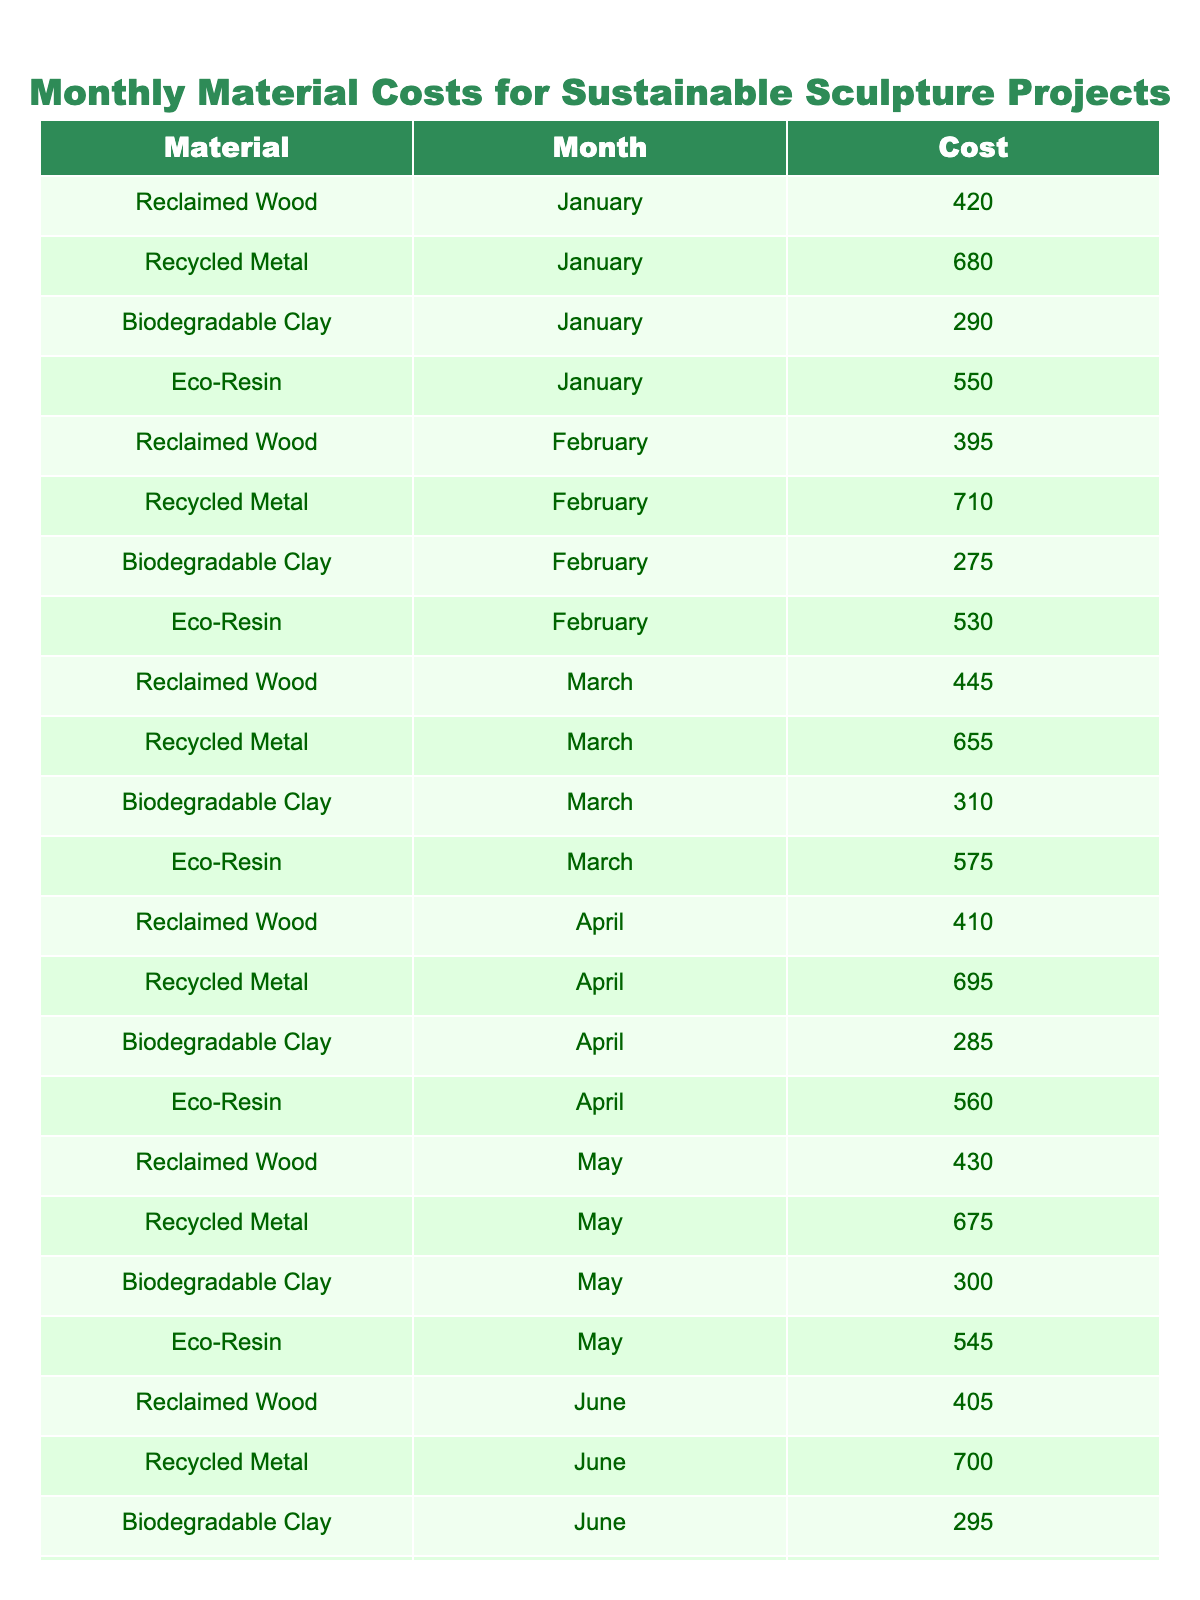What was the total cost of Biodegradable Clay in January? The cost for Biodegradable Clay in January is listed as 290. Since there's only one entry for January, this is the total cost.
Answer: 290 Which month had the highest total cost for Recycled Metal? By examining the costs for Recycled Metal across all months, the values are: 680 (January), 710 (February), 655 (March), 695 (April), 675 (May), 700 (June). The highest value is 710 in February.
Answer: February What is the average cost of Eco-Resin from January to June? The Eco-Resin costs listed from January to June are: 550, 530, 575, 560, 545, and 570. The total cost is 550 + 530 + 575 + 560 + 545 + 570 = 3430. There are 6 months, so the average is 3430 / 6 = 571.67.
Answer: 571.67 Did the cost of Reclaimed Wood increase in March compared to February? The costs for Reclaimed Wood are 395 in February and 445 in March. Since 445 > 395, it indicates an increase from February to March.
Answer: Yes What is the difference between the highest and lowest costs of Biodegradable Clay from January to June? The costs for Biodegradable Clay are: 290 (January), 275 (February), 310 (March), 285 (April), 300 (May), and 295 (June). The highest cost is 310 and the lowest is 275. The difference is 310 - 275 = 35.
Answer: 35 Which material had the highest cumulative cost over the six months? Summing the costs for each material over six months, we get: Reclaimed Wood = 420 + 395 + 445 + 410 + 430 + 405 = 2305, Recycled Metal = 680 + 710 + 655 + 695 + 675 + 700 = 4135, Biodegradable Clay = 290 + 275 + 310 + 285 + 300 + 295 = 1755, Eco-Resin = 550 + 530 + 575 + 560 + 545 + 570 = 3430. The highest cumulative cost is 4135 for Recycled Metal.
Answer: Recycled Metal What was the average monthly cost of sustainable materials for April? In April, the costs were: Reclaimed Wood (410), Recycled Metal (695), Biodegradable Clay (285), and Eco-Resin (560). The total is 410 + 695 + 285 + 560 = 1950. There are 4 materials, so the average is 1950 / 4 = 487.5.
Answer: 487.5 Is the cost of Recycled Metal in June higher than that of Eco-Resin in May? The cost for Recycled Metal in June is 700, while the cost for Eco-Resin in May is 545. Since 700 is greater than 545, the statement is true.
Answer: Yes 